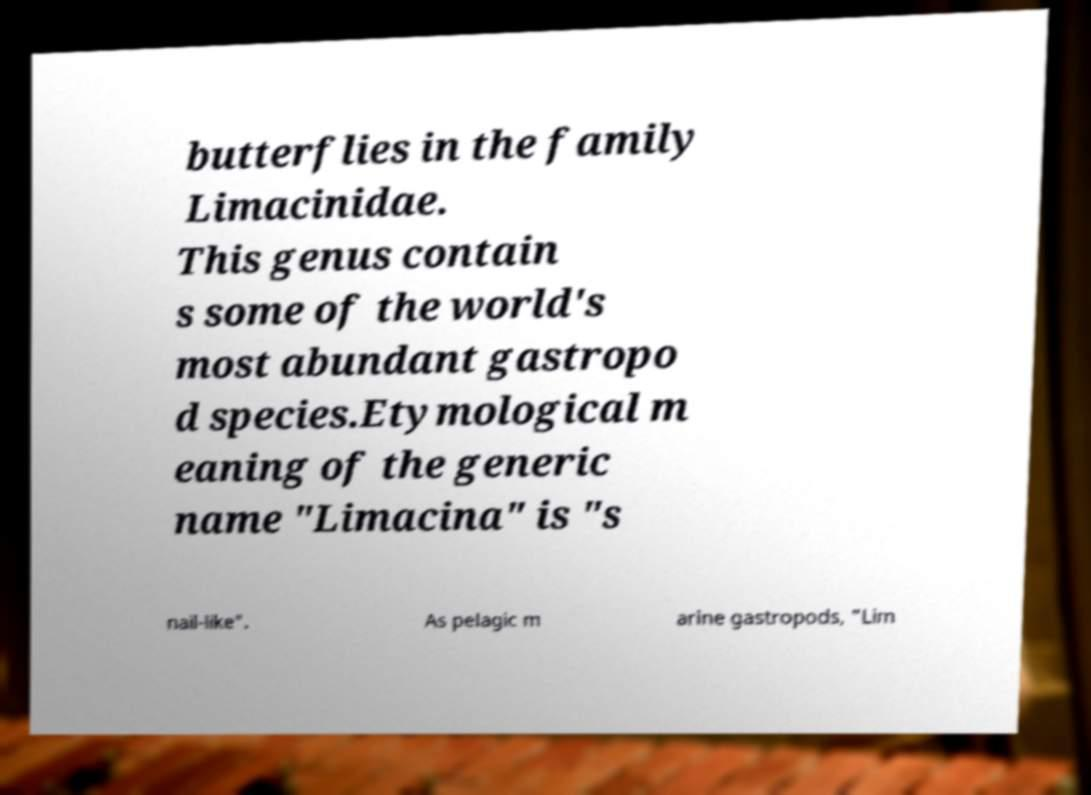Could you extract and type out the text from this image? butterflies in the family Limacinidae. This genus contain s some of the world's most abundant gastropo d species.Etymological m eaning of the generic name "Limacina" is "s nail-like". As pelagic m arine gastropods, "Lim 